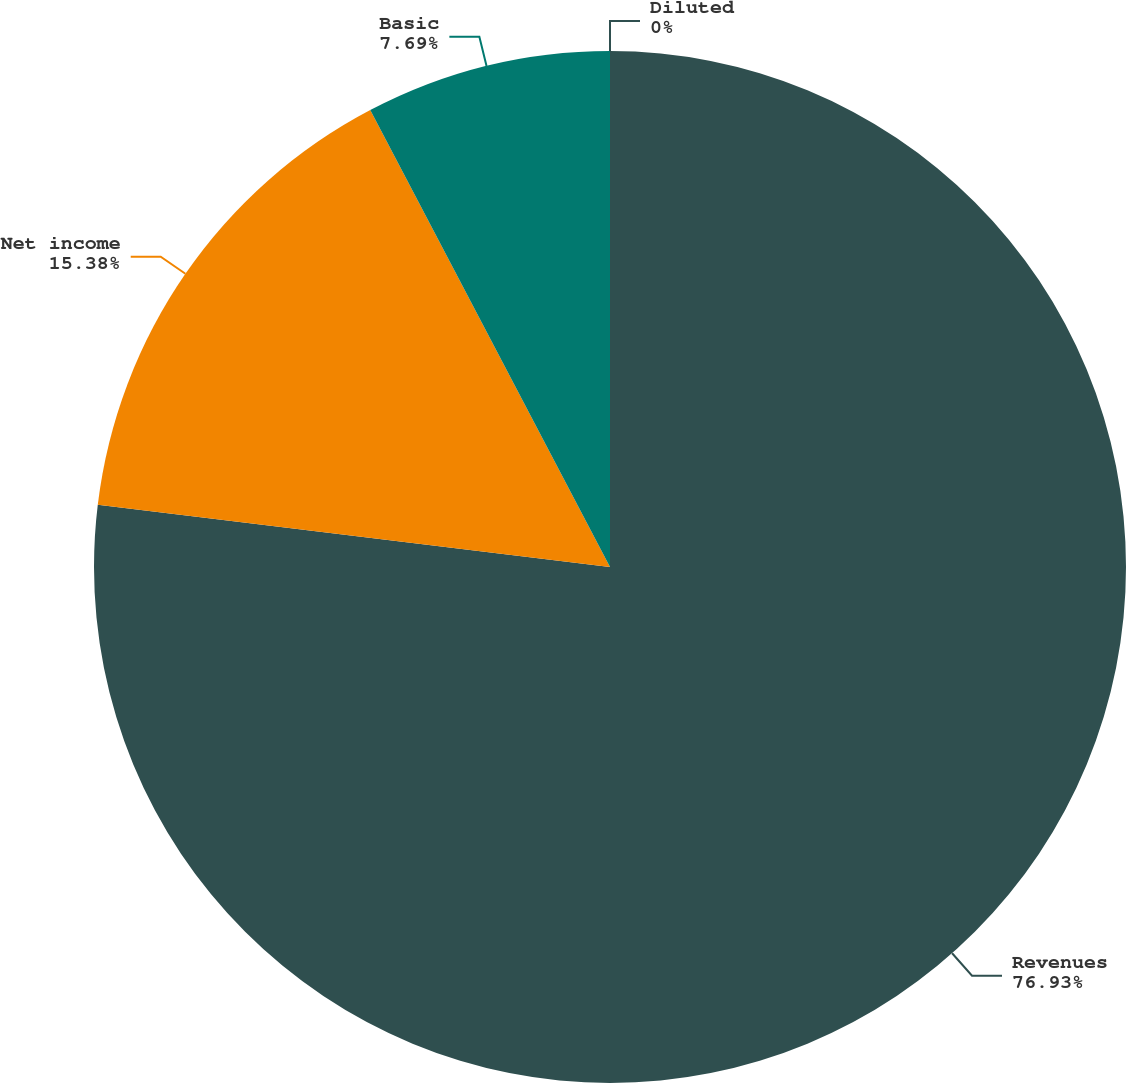Convert chart. <chart><loc_0><loc_0><loc_500><loc_500><pie_chart><fcel>Revenues<fcel>Net income<fcel>Basic<fcel>Diluted<nl><fcel>76.92%<fcel>15.38%<fcel>7.69%<fcel>0.0%<nl></chart> 